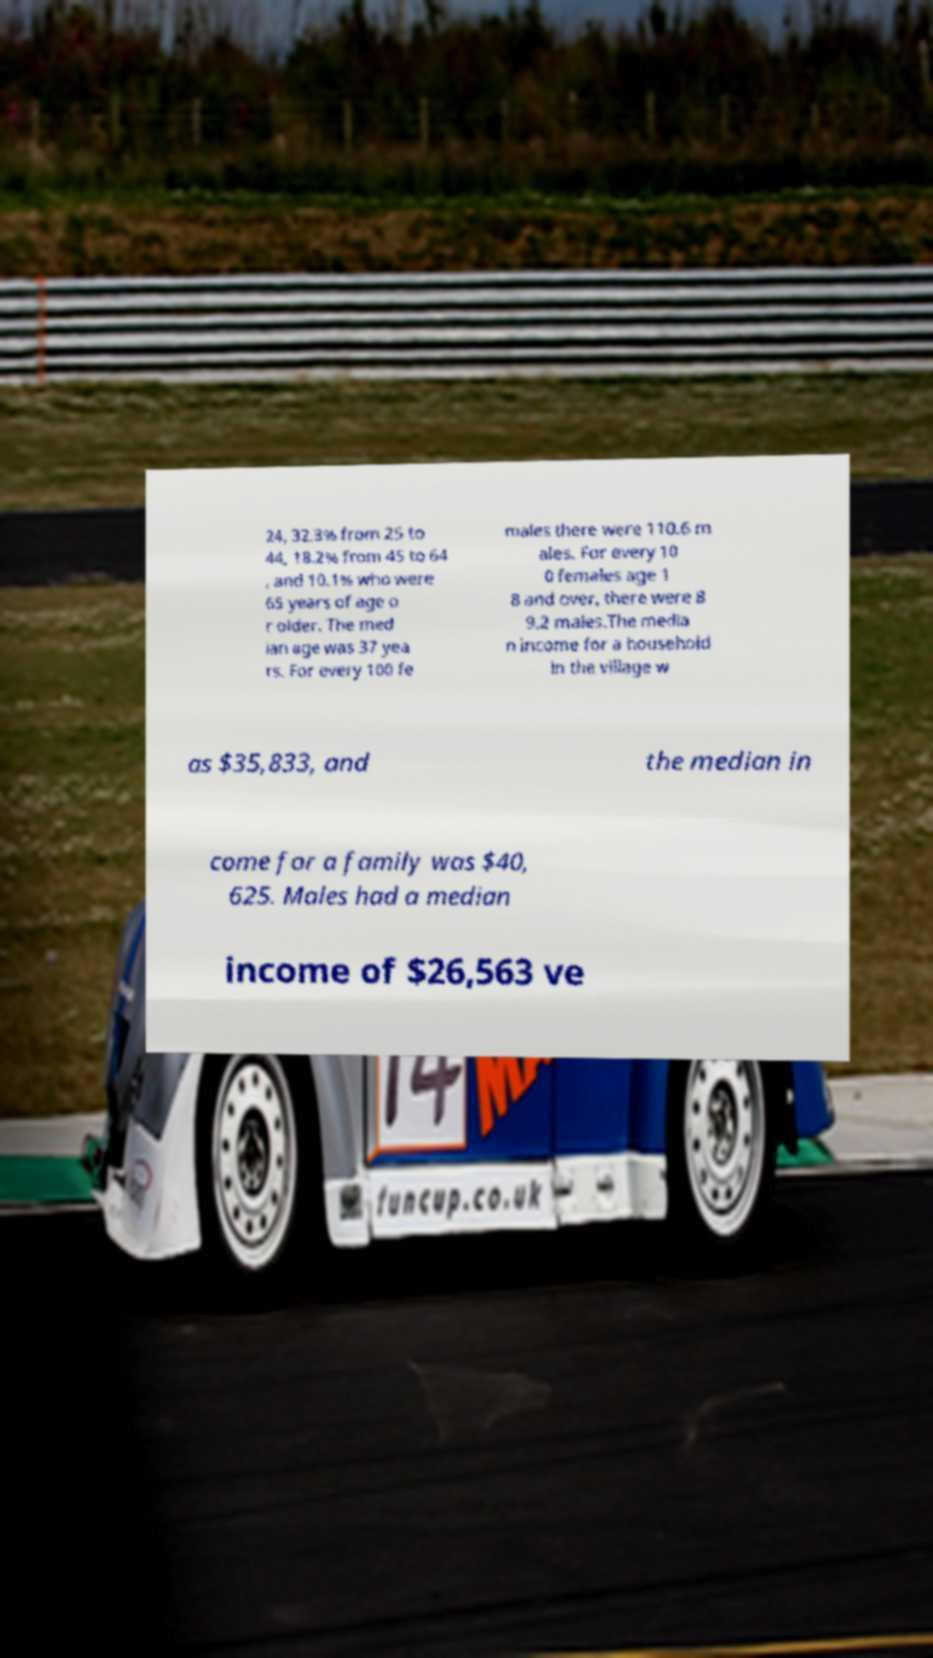I need the written content from this picture converted into text. Can you do that? 24, 32.3% from 25 to 44, 18.2% from 45 to 64 , and 10.1% who were 65 years of age o r older. The med ian age was 37 yea rs. For every 100 fe males there were 110.6 m ales. For every 10 0 females age 1 8 and over, there were 8 9.2 males.The media n income for a household in the village w as $35,833, and the median in come for a family was $40, 625. Males had a median income of $26,563 ve 